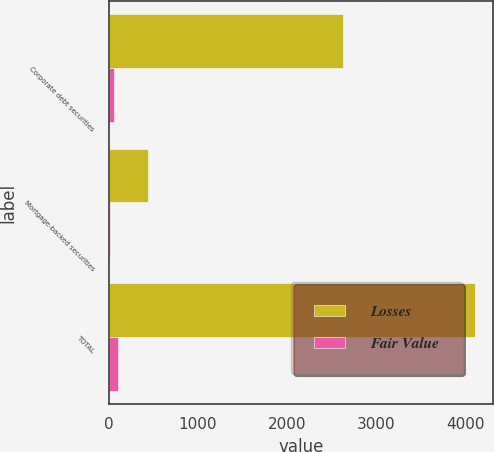Convert chart. <chart><loc_0><loc_0><loc_500><loc_500><stacked_bar_chart><ecel><fcel>Corporate debt securities<fcel>Mortgage-backed securities<fcel>TOTAL<nl><fcel>Losses<fcel>2620<fcel>442<fcel>4101<nl><fcel>Fair Value<fcel>58<fcel>15<fcel>107<nl></chart> 